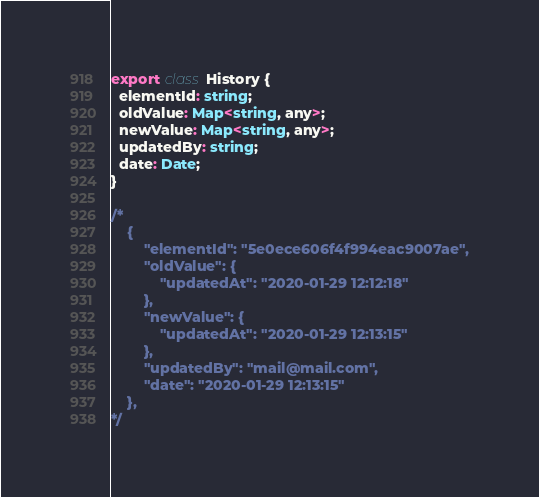Convert code to text. <code><loc_0><loc_0><loc_500><loc_500><_TypeScript_>export class History {
  elementId: string;
  oldValue: Map<string, any>;
  newValue: Map<string, any>;
  updatedBy: string;
  date: Date;
}

/*
    {
        "elementId": "5e0ece606f4f994eac9007ae",
        "oldValue": {
            "updatedAt": "2020-01-29 12:12:18"
        },
        "newValue": {
            "updatedAt": "2020-01-29 12:13:15"
        },
        "updatedBy": "mail@mail.com",
        "date": "2020-01-29 12:13:15"
    },
*/</code> 